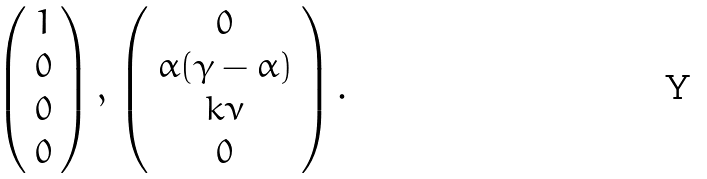Convert formula to latex. <formula><loc_0><loc_0><loc_500><loc_500>\left ( \begin{array} { c } 1 \\ 0 \\ 0 \\ 0 \end{array} \right ) , \, \left ( \begin{array} { c } 0 \\ \alpha ( \gamma - \alpha ) \\ k \nu \\ 0 \end{array} \right ) .</formula> 